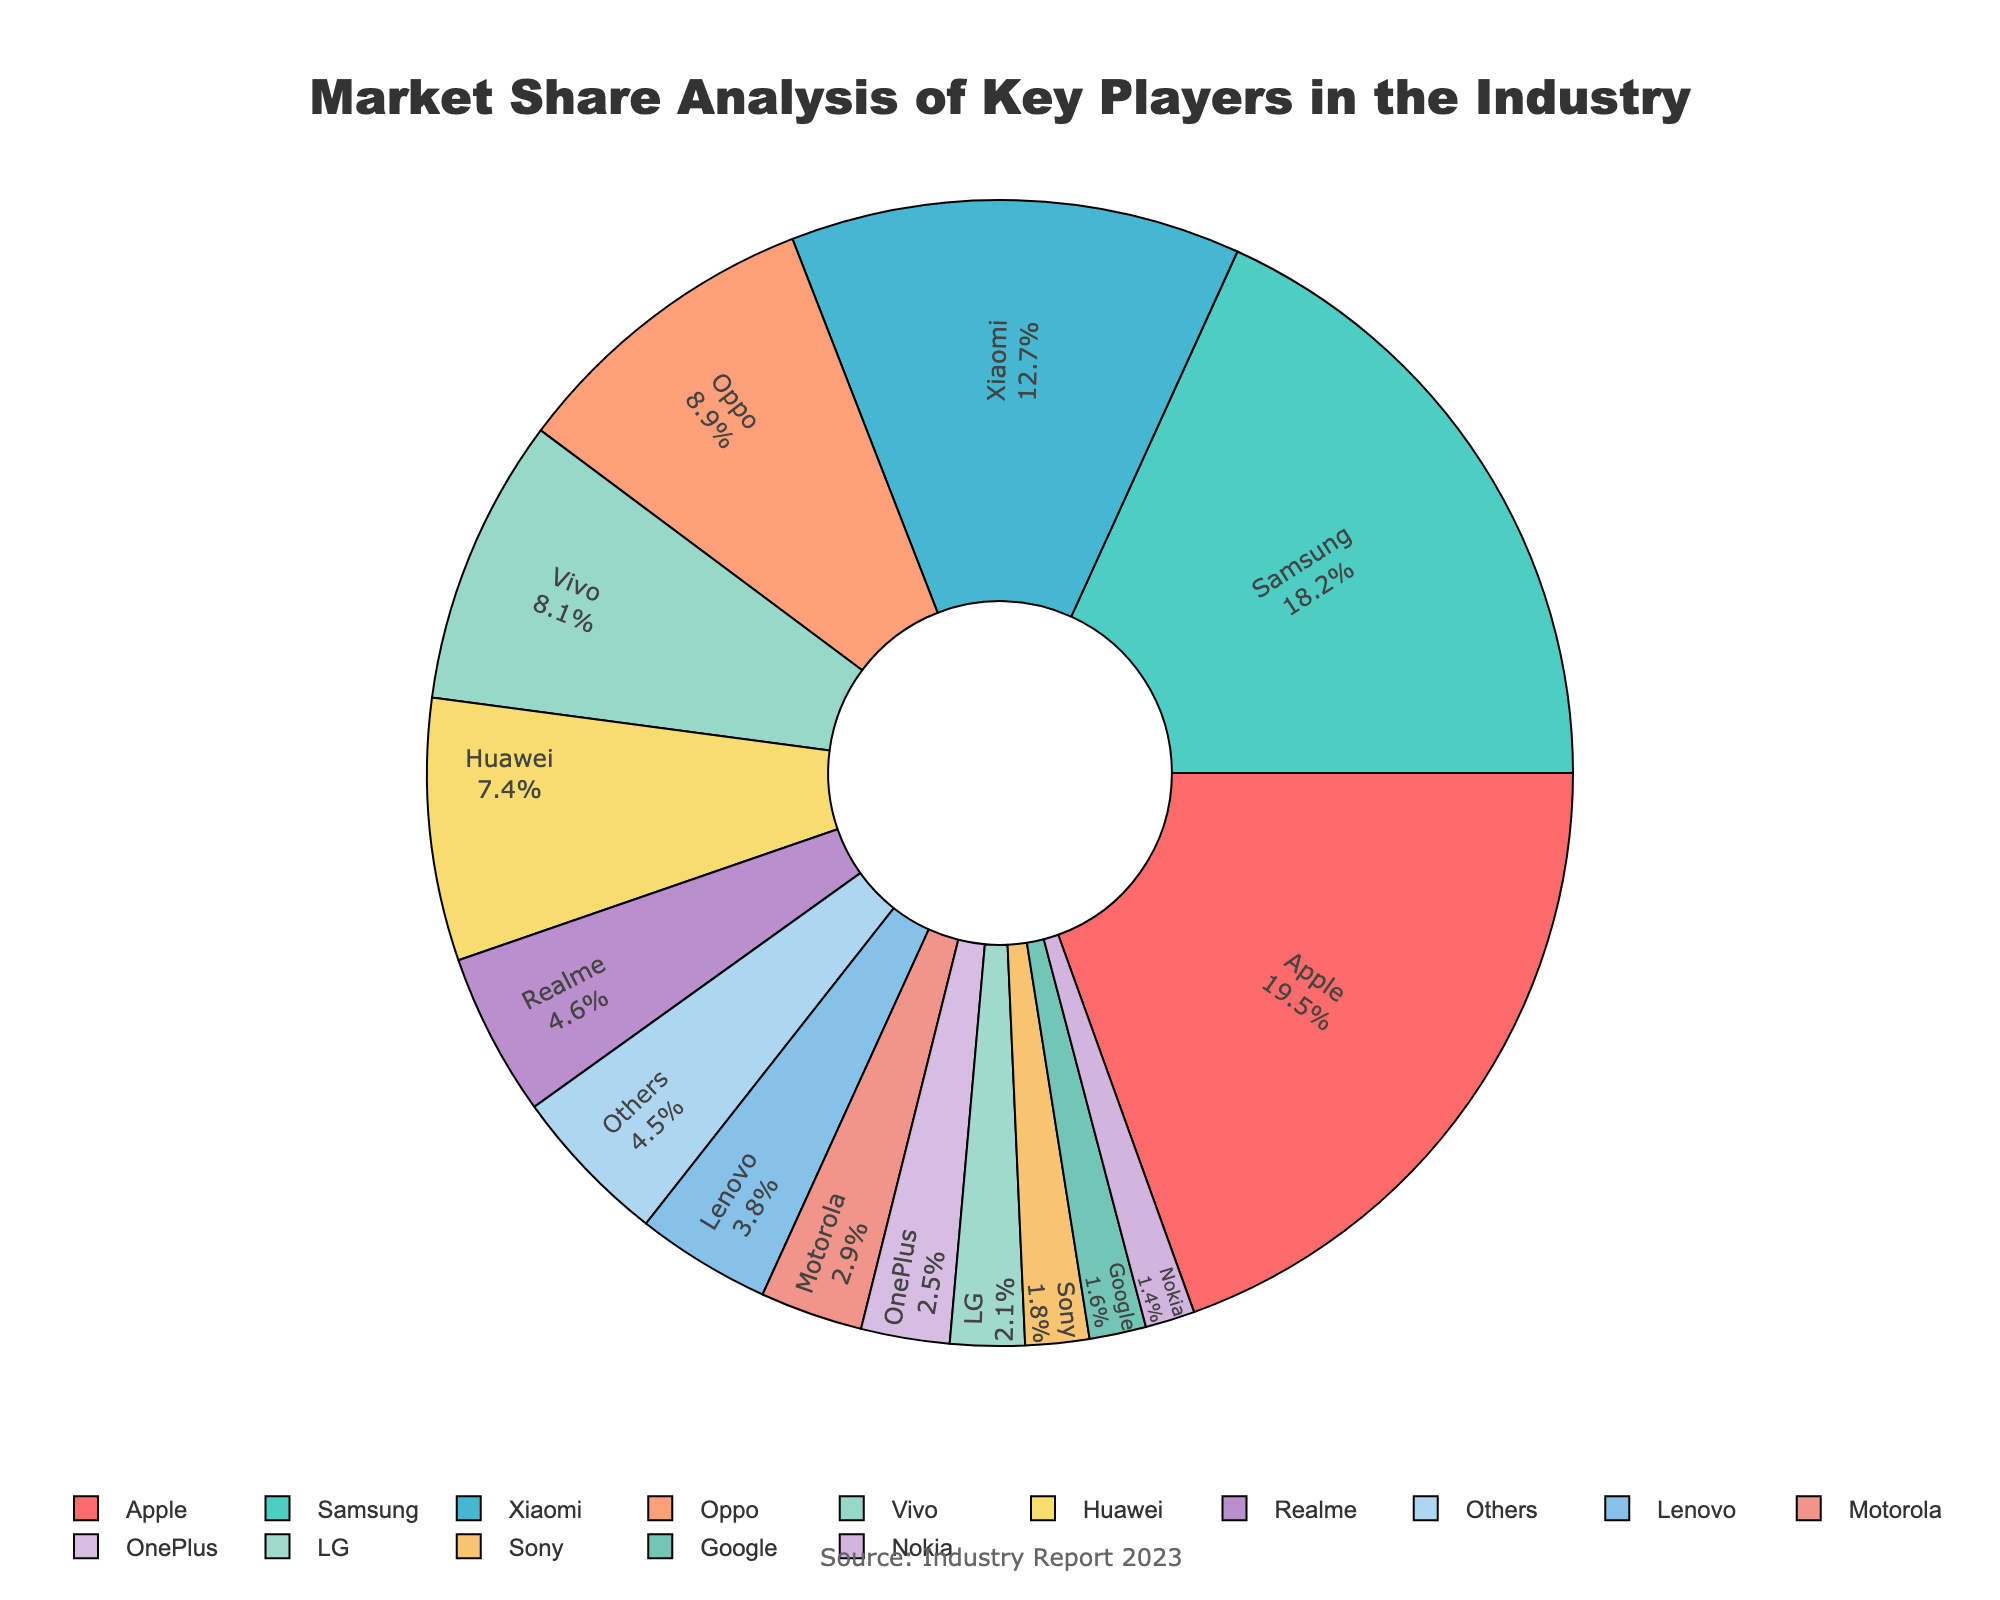What's the combined market share of Apple and Samsung? The market shares for Apple and Samsung are 19.5% and 18.2%, respectively. Adding them together: 19.5 + 18.2 = 37.7
Answer: 37.7% Which company has a larger market share, Huawei or OnePlus? Huawei's market share is 7.4%, and OnePlus's is 2.5%. Comparing these values, 7.4 is larger than 2.5.
Answer: Huawei Which companies are represented with the largest and smallest market shares? The company with the largest market share is Apple with 19.5%, and the company with the smallest market share is Nokia with 1.4%.
Answer: Apple (largest), Nokia (smallest) What is the market share difference between Xiaomi and Vivo? Xiaomi's market share is 12.7%, and Vivo's is 8.1%. Subtracting these values: 12.7 - 8.1 = 4.6
Answer: 4.6% Are there more companies with market shares greater than 5%, or 5% and below? Companies with market shares greater than 5%: Apple, Samsung, Xiaomi, Oppo, Vivo, Huawei (6 companies). Companies with market shares 5% and below: Realme, Lenovo, Motorola, OnePlus, LG, Sony, Google, Nokia, Others (9 entities). Comparing these counts, 9 is more than 6.
Answer: More companies with 5% and below What's the total market share of all companies except for Apple? Total market share of all companies combined is 100%. Subtracting Apple's share: 100 - 19.5 = 80.5
Answer: 80.5% Which company has a market share closest to 10%? Oppo has a market share of 8.9%, which is the closest to 10% among the listed companies.
Answer: Oppo If we combine the market shares for LG, Sony, Google, and Nokia, what do we get? Market shares for LG, Sony, Google, and Nokia are 2.1%, 1.8%, 1.6%, and 1.4% respectively. Adding them up: 2.1 + 1.8 + 1.6 + 1.4 = 6.9
Answer: 6.9% Which company is represented by the blue color in the pie chart? The pie chart doesn't directly label the colors of the segments. However, if we estimate based on common practices, Samsung is a likely candidate, given the second-largest share is often prominently colored like blue.
Answer: Samsung (likely, but needs confirmation) Does Apple’s market share exceed the combined market share of Lenovo, Motorola, OnePlus, and Sony? Lenovo (3.8%), Motorola (2.9%), OnePlus (2.5%), Sony (1.8%) combined share: 3.8 + 2.9 + 2.5 + 1.8 = 11%. Apple's share is 19.5%, which is greater than 11%.
Answer: Yes 